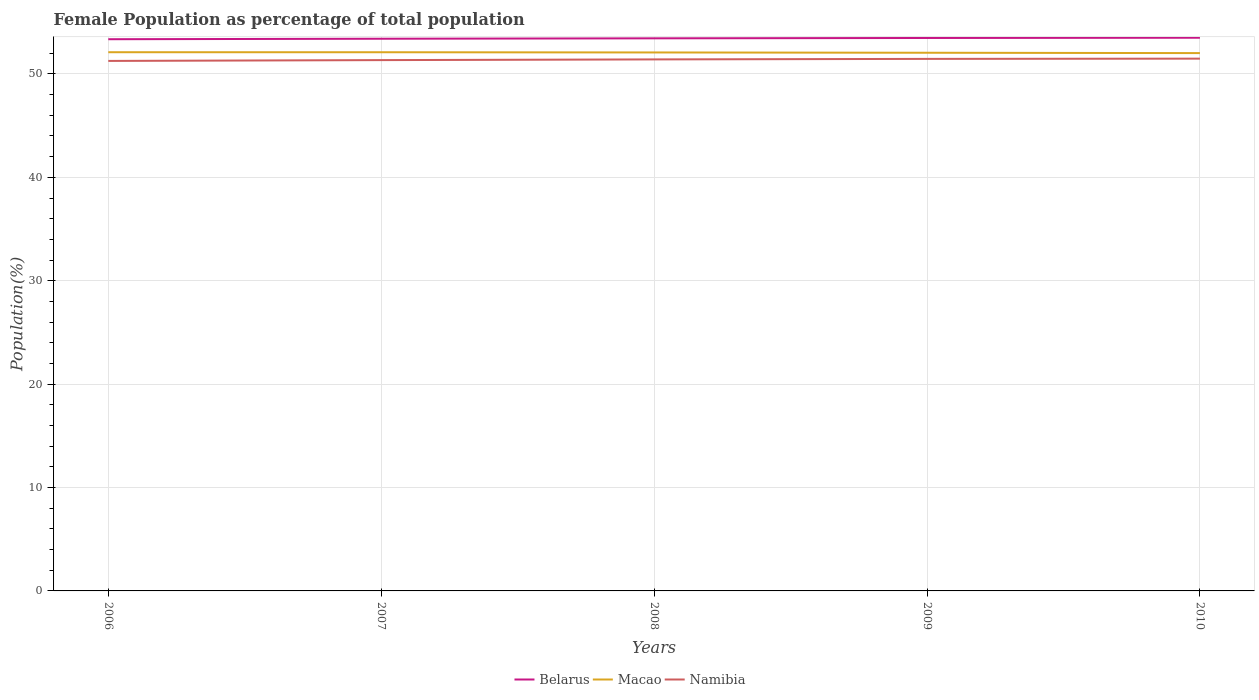How many different coloured lines are there?
Provide a short and direct response. 3. Does the line corresponding to Macao intersect with the line corresponding to Namibia?
Your response must be concise. No. Is the number of lines equal to the number of legend labels?
Your answer should be very brief. Yes. Across all years, what is the maximum female population in in Namibia?
Keep it short and to the point. 51.26. In which year was the female population in in Belarus maximum?
Your answer should be compact. 2006. What is the total female population in in Namibia in the graph?
Your answer should be very brief. -0.2. What is the difference between the highest and the second highest female population in in Belarus?
Provide a succinct answer. 0.14. How many lines are there?
Ensure brevity in your answer.  3. What is the difference between two consecutive major ticks on the Y-axis?
Your answer should be compact. 10. Are the values on the major ticks of Y-axis written in scientific E-notation?
Offer a very short reply. No. Does the graph contain any zero values?
Your answer should be compact. No. Does the graph contain grids?
Provide a succinct answer. Yes. How are the legend labels stacked?
Your answer should be compact. Horizontal. What is the title of the graph?
Your answer should be compact. Female Population as percentage of total population. Does "Puerto Rico" appear as one of the legend labels in the graph?
Your response must be concise. No. What is the label or title of the X-axis?
Keep it short and to the point. Years. What is the label or title of the Y-axis?
Your response must be concise. Population(%). What is the Population(%) of Belarus in 2006?
Offer a very short reply. 53.36. What is the Population(%) of Macao in 2006?
Give a very brief answer. 52.1. What is the Population(%) in Namibia in 2006?
Make the answer very short. 51.26. What is the Population(%) in Belarus in 2007?
Give a very brief answer. 53.4. What is the Population(%) in Macao in 2007?
Keep it short and to the point. 52.1. What is the Population(%) of Namibia in 2007?
Your response must be concise. 51.34. What is the Population(%) of Belarus in 2008?
Give a very brief answer. 53.44. What is the Population(%) in Macao in 2008?
Your response must be concise. 52.08. What is the Population(%) of Namibia in 2008?
Your answer should be very brief. 51.41. What is the Population(%) of Belarus in 2009?
Give a very brief answer. 53.48. What is the Population(%) in Macao in 2009?
Your answer should be very brief. 52.05. What is the Population(%) of Namibia in 2009?
Provide a succinct answer. 51.46. What is the Population(%) of Belarus in 2010?
Keep it short and to the point. 53.5. What is the Population(%) in Macao in 2010?
Provide a short and direct response. 52.02. What is the Population(%) of Namibia in 2010?
Your answer should be compact. 51.48. Across all years, what is the maximum Population(%) of Belarus?
Keep it short and to the point. 53.5. Across all years, what is the maximum Population(%) in Macao?
Keep it short and to the point. 52.1. Across all years, what is the maximum Population(%) of Namibia?
Keep it short and to the point. 51.48. Across all years, what is the minimum Population(%) of Belarus?
Offer a terse response. 53.36. Across all years, what is the minimum Population(%) in Macao?
Provide a short and direct response. 52.02. Across all years, what is the minimum Population(%) in Namibia?
Provide a short and direct response. 51.26. What is the total Population(%) of Belarus in the graph?
Offer a very short reply. 267.19. What is the total Population(%) of Macao in the graph?
Your response must be concise. 260.34. What is the total Population(%) of Namibia in the graph?
Provide a succinct answer. 256.94. What is the difference between the Population(%) of Belarus in 2006 and that in 2007?
Provide a short and direct response. -0.05. What is the difference between the Population(%) in Macao in 2006 and that in 2007?
Your response must be concise. 0. What is the difference between the Population(%) in Namibia in 2006 and that in 2007?
Provide a succinct answer. -0.08. What is the difference between the Population(%) of Belarus in 2006 and that in 2008?
Make the answer very short. -0.09. What is the difference between the Population(%) of Macao in 2006 and that in 2008?
Offer a very short reply. 0.02. What is the difference between the Population(%) of Namibia in 2006 and that in 2008?
Offer a terse response. -0.15. What is the difference between the Population(%) in Belarus in 2006 and that in 2009?
Your response must be concise. -0.12. What is the difference between the Population(%) in Macao in 2006 and that in 2009?
Provide a succinct answer. 0.05. What is the difference between the Population(%) of Namibia in 2006 and that in 2009?
Make the answer very short. -0.2. What is the difference between the Population(%) of Belarus in 2006 and that in 2010?
Your answer should be compact. -0.14. What is the difference between the Population(%) of Macao in 2006 and that in 2010?
Offer a terse response. 0.08. What is the difference between the Population(%) in Namibia in 2006 and that in 2010?
Your answer should be very brief. -0.22. What is the difference between the Population(%) in Belarus in 2007 and that in 2008?
Make the answer very short. -0.04. What is the difference between the Population(%) in Macao in 2007 and that in 2008?
Ensure brevity in your answer.  0.02. What is the difference between the Population(%) of Namibia in 2007 and that in 2008?
Keep it short and to the point. -0.07. What is the difference between the Population(%) in Belarus in 2007 and that in 2009?
Ensure brevity in your answer.  -0.07. What is the difference between the Population(%) of Macao in 2007 and that in 2009?
Offer a terse response. 0.05. What is the difference between the Population(%) of Namibia in 2007 and that in 2009?
Offer a terse response. -0.12. What is the difference between the Population(%) in Belarus in 2007 and that in 2010?
Make the answer very short. -0.1. What is the difference between the Population(%) in Macao in 2007 and that in 2010?
Your answer should be compact. 0.08. What is the difference between the Population(%) in Namibia in 2007 and that in 2010?
Keep it short and to the point. -0.14. What is the difference between the Population(%) in Belarus in 2008 and that in 2009?
Offer a very short reply. -0.03. What is the difference between the Population(%) in Macao in 2008 and that in 2009?
Make the answer very short. 0.03. What is the difference between the Population(%) of Namibia in 2008 and that in 2009?
Offer a terse response. -0.05. What is the difference between the Population(%) in Belarus in 2008 and that in 2010?
Your response must be concise. -0.06. What is the difference between the Population(%) of Macao in 2008 and that in 2010?
Offer a terse response. 0.06. What is the difference between the Population(%) of Namibia in 2008 and that in 2010?
Give a very brief answer. -0.07. What is the difference between the Population(%) in Belarus in 2009 and that in 2010?
Provide a succinct answer. -0.02. What is the difference between the Population(%) of Macao in 2009 and that in 2010?
Provide a short and direct response. 0.03. What is the difference between the Population(%) of Namibia in 2009 and that in 2010?
Make the answer very short. -0.02. What is the difference between the Population(%) in Belarus in 2006 and the Population(%) in Macao in 2007?
Give a very brief answer. 1.26. What is the difference between the Population(%) in Belarus in 2006 and the Population(%) in Namibia in 2007?
Your answer should be very brief. 2.02. What is the difference between the Population(%) in Macao in 2006 and the Population(%) in Namibia in 2007?
Ensure brevity in your answer.  0.76. What is the difference between the Population(%) in Belarus in 2006 and the Population(%) in Macao in 2008?
Make the answer very short. 1.28. What is the difference between the Population(%) of Belarus in 2006 and the Population(%) of Namibia in 2008?
Your response must be concise. 1.95. What is the difference between the Population(%) in Macao in 2006 and the Population(%) in Namibia in 2008?
Keep it short and to the point. 0.7. What is the difference between the Population(%) of Belarus in 2006 and the Population(%) of Macao in 2009?
Offer a very short reply. 1.31. What is the difference between the Population(%) in Belarus in 2006 and the Population(%) in Namibia in 2009?
Provide a succinct answer. 1.9. What is the difference between the Population(%) of Macao in 2006 and the Population(%) of Namibia in 2009?
Provide a succinct answer. 0.65. What is the difference between the Population(%) in Belarus in 2006 and the Population(%) in Macao in 2010?
Offer a terse response. 1.34. What is the difference between the Population(%) of Belarus in 2006 and the Population(%) of Namibia in 2010?
Offer a terse response. 1.88. What is the difference between the Population(%) in Macao in 2006 and the Population(%) in Namibia in 2010?
Ensure brevity in your answer.  0.62. What is the difference between the Population(%) in Belarus in 2007 and the Population(%) in Macao in 2008?
Provide a short and direct response. 1.33. What is the difference between the Population(%) of Belarus in 2007 and the Population(%) of Namibia in 2008?
Offer a terse response. 2. What is the difference between the Population(%) in Macao in 2007 and the Population(%) in Namibia in 2008?
Offer a very short reply. 0.69. What is the difference between the Population(%) in Belarus in 2007 and the Population(%) in Macao in 2009?
Make the answer very short. 1.36. What is the difference between the Population(%) of Belarus in 2007 and the Population(%) of Namibia in 2009?
Offer a very short reply. 1.95. What is the difference between the Population(%) in Macao in 2007 and the Population(%) in Namibia in 2009?
Your response must be concise. 0.64. What is the difference between the Population(%) of Belarus in 2007 and the Population(%) of Macao in 2010?
Your answer should be very brief. 1.39. What is the difference between the Population(%) of Belarus in 2007 and the Population(%) of Namibia in 2010?
Your answer should be compact. 1.92. What is the difference between the Population(%) in Macao in 2007 and the Population(%) in Namibia in 2010?
Your answer should be compact. 0.62. What is the difference between the Population(%) in Belarus in 2008 and the Population(%) in Macao in 2009?
Provide a succinct answer. 1.4. What is the difference between the Population(%) in Belarus in 2008 and the Population(%) in Namibia in 2009?
Your answer should be very brief. 1.99. What is the difference between the Population(%) in Macao in 2008 and the Population(%) in Namibia in 2009?
Provide a short and direct response. 0.62. What is the difference between the Population(%) of Belarus in 2008 and the Population(%) of Macao in 2010?
Keep it short and to the point. 1.43. What is the difference between the Population(%) of Belarus in 2008 and the Population(%) of Namibia in 2010?
Your answer should be very brief. 1.96. What is the difference between the Population(%) of Macao in 2008 and the Population(%) of Namibia in 2010?
Provide a short and direct response. 0.6. What is the difference between the Population(%) of Belarus in 2009 and the Population(%) of Macao in 2010?
Offer a terse response. 1.46. What is the difference between the Population(%) in Belarus in 2009 and the Population(%) in Namibia in 2010?
Offer a very short reply. 2. What is the difference between the Population(%) of Macao in 2009 and the Population(%) of Namibia in 2010?
Provide a short and direct response. 0.57. What is the average Population(%) of Belarus per year?
Provide a short and direct response. 53.44. What is the average Population(%) of Macao per year?
Offer a very short reply. 52.07. What is the average Population(%) in Namibia per year?
Ensure brevity in your answer.  51.39. In the year 2006, what is the difference between the Population(%) in Belarus and Population(%) in Macao?
Your response must be concise. 1.26. In the year 2006, what is the difference between the Population(%) in Belarus and Population(%) in Namibia?
Provide a short and direct response. 2.1. In the year 2006, what is the difference between the Population(%) of Macao and Population(%) of Namibia?
Offer a very short reply. 0.84. In the year 2007, what is the difference between the Population(%) in Belarus and Population(%) in Macao?
Make the answer very short. 1.31. In the year 2007, what is the difference between the Population(%) in Belarus and Population(%) in Namibia?
Offer a very short reply. 2.07. In the year 2007, what is the difference between the Population(%) in Macao and Population(%) in Namibia?
Offer a terse response. 0.76. In the year 2008, what is the difference between the Population(%) in Belarus and Population(%) in Macao?
Your answer should be compact. 1.37. In the year 2008, what is the difference between the Population(%) of Belarus and Population(%) of Namibia?
Provide a succinct answer. 2.04. In the year 2008, what is the difference between the Population(%) of Macao and Population(%) of Namibia?
Provide a short and direct response. 0.67. In the year 2009, what is the difference between the Population(%) of Belarus and Population(%) of Macao?
Provide a succinct answer. 1.43. In the year 2009, what is the difference between the Population(%) in Belarus and Population(%) in Namibia?
Give a very brief answer. 2.02. In the year 2009, what is the difference between the Population(%) in Macao and Population(%) in Namibia?
Offer a terse response. 0.59. In the year 2010, what is the difference between the Population(%) of Belarus and Population(%) of Macao?
Your answer should be very brief. 1.49. In the year 2010, what is the difference between the Population(%) of Belarus and Population(%) of Namibia?
Your answer should be compact. 2.02. In the year 2010, what is the difference between the Population(%) in Macao and Population(%) in Namibia?
Your answer should be very brief. 0.54. What is the ratio of the Population(%) in Belarus in 2006 to that in 2007?
Make the answer very short. 1. What is the ratio of the Population(%) of Macao in 2006 to that in 2007?
Offer a very short reply. 1. What is the ratio of the Population(%) in Belarus in 2006 to that in 2008?
Make the answer very short. 1. What is the ratio of the Population(%) in Macao in 2006 to that in 2008?
Give a very brief answer. 1. What is the ratio of the Population(%) of Namibia in 2006 to that in 2008?
Make the answer very short. 1. What is the ratio of the Population(%) of Belarus in 2006 to that in 2009?
Offer a very short reply. 1. What is the ratio of the Population(%) in Belarus in 2006 to that in 2010?
Keep it short and to the point. 1. What is the ratio of the Population(%) in Namibia in 2006 to that in 2010?
Provide a succinct answer. 1. What is the ratio of the Population(%) in Belarus in 2007 to that in 2008?
Ensure brevity in your answer.  1. What is the ratio of the Population(%) of Macao in 2007 to that in 2008?
Offer a very short reply. 1. What is the ratio of the Population(%) in Namibia in 2007 to that in 2008?
Your answer should be very brief. 1. What is the ratio of the Population(%) in Belarus in 2007 to that in 2009?
Your answer should be very brief. 1. What is the ratio of the Population(%) of Namibia in 2007 to that in 2009?
Provide a succinct answer. 1. What is the ratio of the Population(%) of Belarus in 2007 to that in 2010?
Ensure brevity in your answer.  1. What is the ratio of the Population(%) in Belarus in 2008 to that in 2009?
Your response must be concise. 1. What is the ratio of the Population(%) in Macao in 2008 to that in 2009?
Your answer should be compact. 1. What is the ratio of the Population(%) in Namibia in 2008 to that in 2009?
Give a very brief answer. 1. What is the ratio of the Population(%) of Belarus in 2008 to that in 2010?
Your answer should be compact. 1. What is the ratio of the Population(%) in Namibia in 2008 to that in 2010?
Your response must be concise. 1. What is the ratio of the Population(%) in Belarus in 2009 to that in 2010?
Your answer should be compact. 1. What is the difference between the highest and the second highest Population(%) of Belarus?
Your response must be concise. 0.02. What is the difference between the highest and the second highest Population(%) in Macao?
Your answer should be very brief. 0. What is the difference between the highest and the second highest Population(%) in Namibia?
Make the answer very short. 0.02. What is the difference between the highest and the lowest Population(%) in Belarus?
Ensure brevity in your answer.  0.14. What is the difference between the highest and the lowest Population(%) of Macao?
Make the answer very short. 0.08. What is the difference between the highest and the lowest Population(%) of Namibia?
Give a very brief answer. 0.22. 